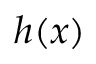Convert formula to latex. <formula><loc_0><loc_0><loc_500><loc_500>h ( x )</formula> 